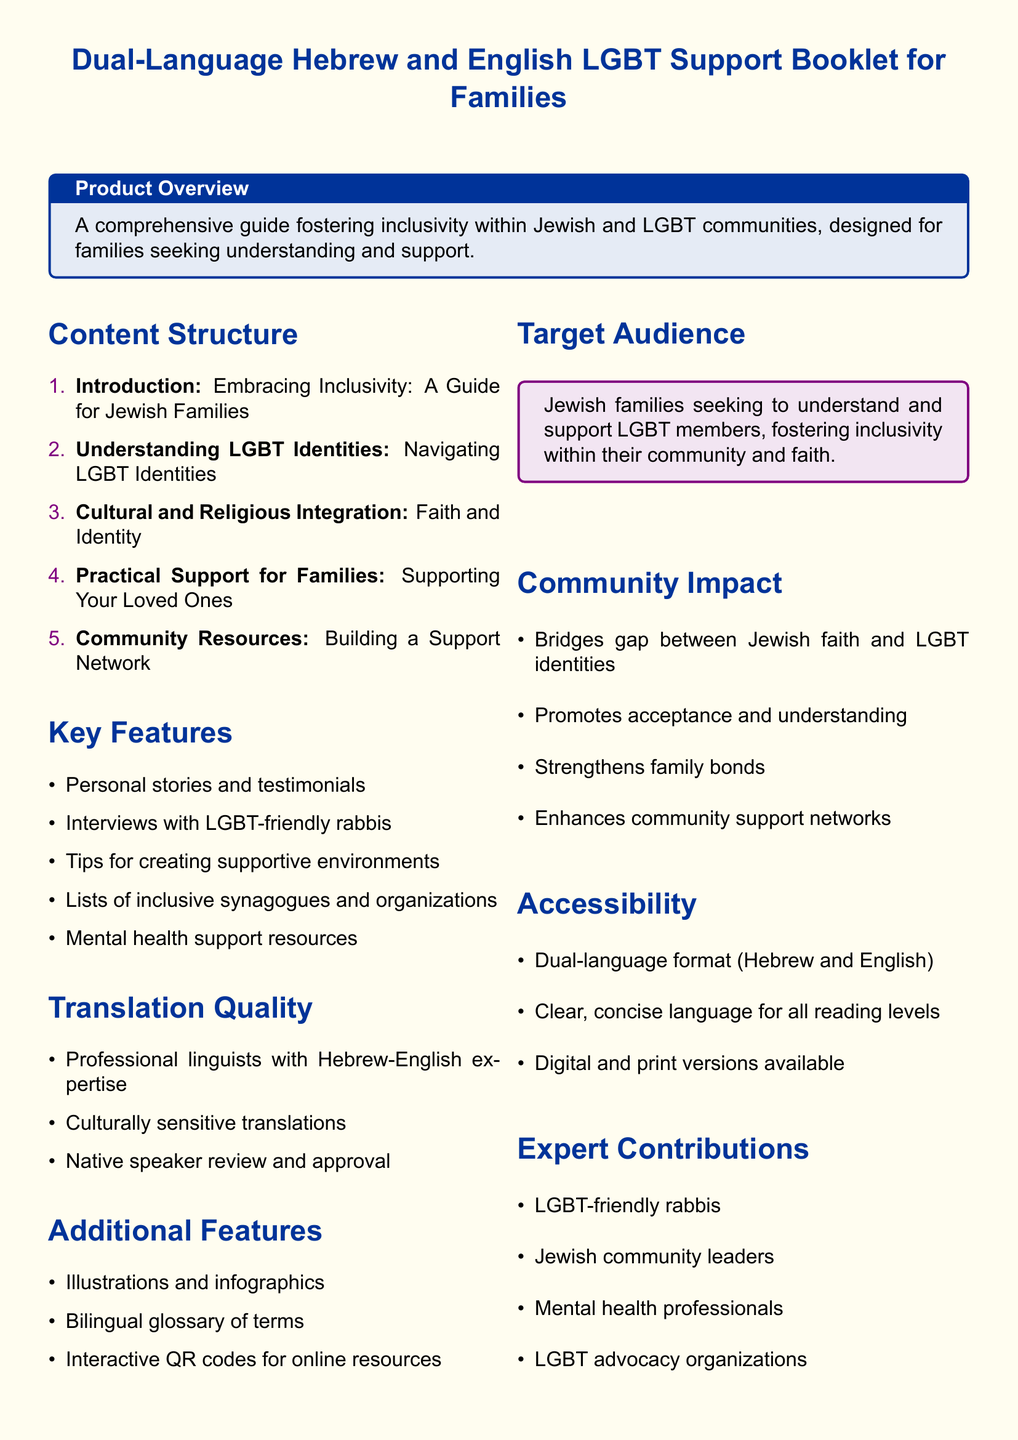what is the title of the booklet? The title is prominently displayed at the top of the document.
Answer: Dual-Language Hebrew and English LGBT Support Booklet for Families how many sections are listed in the Content Structure? The number of sections can be counted under the content structure heading.
Answer: 5 who contributed to the Expert Contributions section? The section lists various contributors who work within the community.
Answer: LGBT-friendly rabbis, Jewish community leaders, mental health professionals, LGBT advocacy organizations what do the illustrations and infographics aim to support? This feature is listed under Additional Features and relates to understanding the content visually.
Answer: Understanding complex concepts what type of language is used for the translation? The document specifies attributes about translation in the Translation Quality section.
Answer: Culturally sensitive translations what is the target audience of the booklet? The target audience is clearly stated in the product specification.
Answer: Jewish families seeking to understand and support LGBT members how does the booklet aim to enhance community support networks? The Community Impact section outlines outcomes of using the booklet.
Answer: Strengthens family bonds what format does the booklet come in? The Accessibility section describes the formats available.
Answer: Digital and print versions 